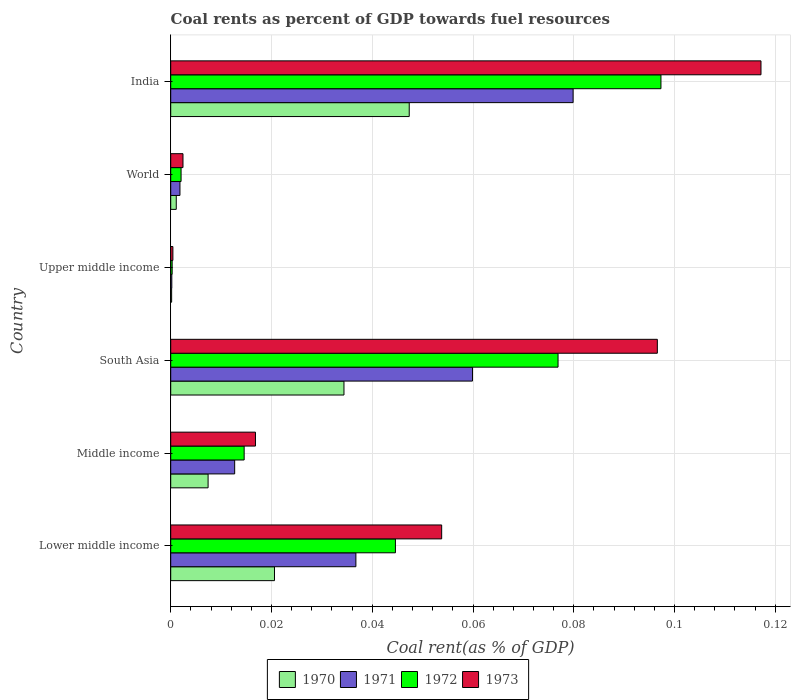How many groups of bars are there?
Offer a terse response. 6. Are the number of bars per tick equal to the number of legend labels?
Provide a succinct answer. Yes. Are the number of bars on each tick of the Y-axis equal?
Your response must be concise. Yes. What is the label of the 5th group of bars from the top?
Give a very brief answer. Middle income. What is the coal rent in 1973 in India?
Make the answer very short. 0.12. Across all countries, what is the maximum coal rent in 1970?
Give a very brief answer. 0.05. Across all countries, what is the minimum coal rent in 1971?
Your response must be concise. 0. In which country was the coal rent in 1970 maximum?
Offer a very short reply. India. In which country was the coal rent in 1970 minimum?
Provide a short and direct response. Upper middle income. What is the total coal rent in 1971 in the graph?
Provide a short and direct response. 0.19. What is the difference between the coal rent in 1970 in South Asia and that in Upper middle income?
Your answer should be very brief. 0.03. What is the difference between the coal rent in 1970 in India and the coal rent in 1971 in Middle income?
Provide a short and direct response. 0.03. What is the average coal rent in 1971 per country?
Provide a succinct answer. 0.03. What is the difference between the coal rent in 1971 and coal rent in 1973 in South Asia?
Your answer should be very brief. -0.04. In how many countries, is the coal rent in 1972 greater than 0.028 %?
Provide a succinct answer. 3. What is the ratio of the coal rent in 1970 in Middle income to that in World?
Your response must be concise. 6.74. Is the difference between the coal rent in 1971 in Middle income and South Asia greater than the difference between the coal rent in 1973 in Middle income and South Asia?
Give a very brief answer. Yes. What is the difference between the highest and the second highest coal rent in 1972?
Make the answer very short. 0.02. What is the difference between the highest and the lowest coal rent in 1972?
Your response must be concise. 0.1. What does the 1st bar from the top in Middle income represents?
Make the answer very short. 1973. What does the 4th bar from the bottom in India represents?
Keep it short and to the point. 1973. Is it the case that in every country, the sum of the coal rent in 1970 and coal rent in 1973 is greater than the coal rent in 1972?
Give a very brief answer. Yes. How many bars are there?
Keep it short and to the point. 24. Are all the bars in the graph horizontal?
Offer a terse response. Yes. Are the values on the major ticks of X-axis written in scientific E-notation?
Offer a terse response. No. Does the graph contain grids?
Offer a terse response. Yes. How many legend labels are there?
Ensure brevity in your answer.  4. How are the legend labels stacked?
Provide a succinct answer. Horizontal. What is the title of the graph?
Give a very brief answer. Coal rents as percent of GDP towards fuel resources. Does "1989" appear as one of the legend labels in the graph?
Give a very brief answer. No. What is the label or title of the X-axis?
Make the answer very short. Coal rent(as % of GDP). What is the Coal rent(as % of GDP) of 1970 in Lower middle income?
Make the answer very short. 0.02. What is the Coal rent(as % of GDP) of 1971 in Lower middle income?
Your answer should be compact. 0.04. What is the Coal rent(as % of GDP) of 1972 in Lower middle income?
Your response must be concise. 0.04. What is the Coal rent(as % of GDP) in 1973 in Lower middle income?
Provide a short and direct response. 0.05. What is the Coal rent(as % of GDP) in 1970 in Middle income?
Provide a short and direct response. 0.01. What is the Coal rent(as % of GDP) in 1971 in Middle income?
Your answer should be very brief. 0.01. What is the Coal rent(as % of GDP) in 1972 in Middle income?
Give a very brief answer. 0.01. What is the Coal rent(as % of GDP) in 1973 in Middle income?
Your response must be concise. 0.02. What is the Coal rent(as % of GDP) in 1970 in South Asia?
Your response must be concise. 0.03. What is the Coal rent(as % of GDP) of 1971 in South Asia?
Your answer should be very brief. 0.06. What is the Coal rent(as % of GDP) of 1972 in South Asia?
Offer a terse response. 0.08. What is the Coal rent(as % of GDP) in 1973 in South Asia?
Your answer should be compact. 0.1. What is the Coal rent(as % of GDP) in 1970 in Upper middle income?
Your answer should be compact. 0. What is the Coal rent(as % of GDP) of 1971 in Upper middle income?
Keep it short and to the point. 0. What is the Coal rent(as % of GDP) in 1972 in Upper middle income?
Provide a succinct answer. 0. What is the Coal rent(as % of GDP) of 1973 in Upper middle income?
Ensure brevity in your answer.  0. What is the Coal rent(as % of GDP) in 1970 in World?
Make the answer very short. 0. What is the Coal rent(as % of GDP) of 1971 in World?
Your answer should be very brief. 0. What is the Coal rent(as % of GDP) of 1972 in World?
Offer a terse response. 0. What is the Coal rent(as % of GDP) of 1973 in World?
Make the answer very short. 0. What is the Coal rent(as % of GDP) in 1970 in India?
Make the answer very short. 0.05. What is the Coal rent(as % of GDP) in 1971 in India?
Give a very brief answer. 0.08. What is the Coal rent(as % of GDP) in 1972 in India?
Your answer should be compact. 0.1. What is the Coal rent(as % of GDP) of 1973 in India?
Your answer should be very brief. 0.12. Across all countries, what is the maximum Coal rent(as % of GDP) in 1970?
Keep it short and to the point. 0.05. Across all countries, what is the maximum Coal rent(as % of GDP) of 1971?
Your response must be concise. 0.08. Across all countries, what is the maximum Coal rent(as % of GDP) of 1972?
Provide a short and direct response. 0.1. Across all countries, what is the maximum Coal rent(as % of GDP) in 1973?
Your answer should be compact. 0.12. Across all countries, what is the minimum Coal rent(as % of GDP) in 1970?
Ensure brevity in your answer.  0. Across all countries, what is the minimum Coal rent(as % of GDP) of 1971?
Make the answer very short. 0. Across all countries, what is the minimum Coal rent(as % of GDP) of 1972?
Provide a succinct answer. 0. Across all countries, what is the minimum Coal rent(as % of GDP) in 1973?
Provide a short and direct response. 0. What is the total Coal rent(as % of GDP) of 1970 in the graph?
Ensure brevity in your answer.  0.11. What is the total Coal rent(as % of GDP) of 1971 in the graph?
Your answer should be compact. 0.19. What is the total Coal rent(as % of GDP) of 1972 in the graph?
Ensure brevity in your answer.  0.24. What is the total Coal rent(as % of GDP) of 1973 in the graph?
Offer a very short reply. 0.29. What is the difference between the Coal rent(as % of GDP) of 1970 in Lower middle income and that in Middle income?
Your answer should be very brief. 0.01. What is the difference between the Coal rent(as % of GDP) in 1971 in Lower middle income and that in Middle income?
Your response must be concise. 0.02. What is the difference between the Coal rent(as % of GDP) in 1973 in Lower middle income and that in Middle income?
Offer a terse response. 0.04. What is the difference between the Coal rent(as % of GDP) of 1970 in Lower middle income and that in South Asia?
Give a very brief answer. -0.01. What is the difference between the Coal rent(as % of GDP) of 1971 in Lower middle income and that in South Asia?
Ensure brevity in your answer.  -0.02. What is the difference between the Coal rent(as % of GDP) of 1972 in Lower middle income and that in South Asia?
Your answer should be very brief. -0.03. What is the difference between the Coal rent(as % of GDP) in 1973 in Lower middle income and that in South Asia?
Make the answer very short. -0.04. What is the difference between the Coal rent(as % of GDP) of 1970 in Lower middle income and that in Upper middle income?
Ensure brevity in your answer.  0.02. What is the difference between the Coal rent(as % of GDP) of 1971 in Lower middle income and that in Upper middle income?
Ensure brevity in your answer.  0.04. What is the difference between the Coal rent(as % of GDP) in 1972 in Lower middle income and that in Upper middle income?
Offer a very short reply. 0.04. What is the difference between the Coal rent(as % of GDP) in 1973 in Lower middle income and that in Upper middle income?
Offer a very short reply. 0.05. What is the difference between the Coal rent(as % of GDP) in 1970 in Lower middle income and that in World?
Make the answer very short. 0.02. What is the difference between the Coal rent(as % of GDP) in 1971 in Lower middle income and that in World?
Keep it short and to the point. 0.03. What is the difference between the Coal rent(as % of GDP) in 1972 in Lower middle income and that in World?
Give a very brief answer. 0.04. What is the difference between the Coal rent(as % of GDP) of 1973 in Lower middle income and that in World?
Provide a succinct answer. 0.05. What is the difference between the Coal rent(as % of GDP) of 1970 in Lower middle income and that in India?
Make the answer very short. -0.03. What is the difference between the Coal rent(as % of GDP) in 1971 in Lower middle income and that in India?
Your response must be concise. -0.04. What is the difference between the Coal rent(as % of GDP) of 1972 in Lower middle income and that in India?
Offer a terse response. -0.05. What is the difference between the Coal rent(as % of GDP) of 1973 in Lower middle income and that in India?
Offer a terse response. -0.06. What is the difference between the Coal rent(as % of GDP) in 1970 in Middle income and that in South Asia?
Give a very brief answer. -0.03. What is the difference between the Coal rent(as % of GDP) of 1971 in Middle income and that in South Asia?
Your response must be concise. -0.05. What is the difference between the Coal rent(as % of GDP) in 1972 in Middle income and that in South Asia?
Provide a succinct answer. -0.06. What is the difference between the Coal rent(as % of GDP) in 1973 in Middle income and that in South Asia?
Keep it short and to the point. -0.08. What is the difference between the Coal rent(as % of GDP) of 1970 in Middle income and that in Upper middle income?
Make the answer very short. 0.01. What is the difference between the Coal rent(as % of GDP) of 1971 in Middle income and that in Upper middle income?
Your answer should be very brief. 0.01. What is the difference between the Coal rent(as % of GDP) in 1972 in Middle income and that in Upper middle income?
Offer a terse response. 0.01. What is the difference between the Coal rent(as % of GDP) in 1973 in Middle income and that in Upper middle income?
Keep it short and to the point. 0.02. What is the difference between the Coal rent(as % of GDP) in 1970 in Middle income and that in World?
Offer a terse response. 0.01. What is the difference between the Coal rent(as % of GDP) of 1971 in Middle income and that in World?
Keep it short and to the point. 0.01. What is the difference between the Coal rent(as % of GDP) in 1972 in Middle income and that in World?
Provide a succinct answer. 0.01. What is the difference between the Coal rent(as % of GDP) in 1973 in Middle income and that in World?
Offer a very short reply. 0.01. What is the difference between the Coal rent(as % of GDP) in 1970 in Middle income and that in India?
Provide a succinct answer. -0.04. What is the difference between the Coal rent(as % of GDP) in 1971 in Middle income and that in India?
Provide a short and direct response. -0.07. What is the difference between the Coal rent(as % of GDP) of 1972 in Middle income and that in India?
Ensure brevity in your answer.  -0.08. What is the difference between the Coal rent(as % of GDP) in 1973 in Middle income and that in India?
Your answer should be very brief. -0.1. What is the difference between the Coal rent(as % of GDP) in 1970 in South Asia and that in Upper middle income?
Make the answer very short. 0.03. What is the difference between the Coal rent(as % of GDP) in 1971 in South Asia and that in Upper middle income?
Offer a terse response. 0.06. What is the difference between the Coal rent(as % of GDP) of 1972 in South Asia and that in Upper middle income?
Offer a very short reply. 0.08. What is the difference between the Coal rent(as % of GDP) in 1973 in South Asia and that in Upper middle income?
Provide a short and direct response. 0.1. What is the difference between the Coal rent(as % of GDP) of 1971 in South Asia and that in World?
Your response must be concise. 0.06. What is the difference between the Coal rent(as % of GDP) in 1972 in South Asia and that in World?
Ensure brevity in your answer.  0.07. What is the difference between the Coal rent(as % of GDP) in 1973 in South Asia and that in World?
Your answer should be very brief. 0.09. What is the difference between the Coal rent(as % of GDP) in 1970 in South Asia and that in India?
Offer a terse response. -0.01. What is the difference between the Coal rent(as % of GDP) in 1971 in South Asia and that in India?
Your answer should be compact. -0.02. What is the difference between the Coal rent(as % of GDP) in 1972 in South Asia and that in India?
Keep it short and to the point. -0.02. What is the difference between the Coal rent(as % of GDP) in 1973 in South Asia and that in India?
Give a very brief answer. -0.02. What is the difference between the Coal rent(as % of GDP) of 1970 in Upper middle income and that in World?
Keep it short and to the point. -0. What is the difference between the Coal rent(as % of GDP) in 1971 in Upper middle income and that in World?
Your response must be concise. -0. What is the difference between the Coal rent(as % of GDP) in 1972 in Upper middle income and that in World?
Your answer should be compact. -0. What is the difference between the Coal rent(as % of GDP) in 1973 in Upper middle income and that in World?
Provide a short and direct response. -0. What is the difference between the Coal rent(as % of GDP) of 1970 in Upper middle income and that in India?
Your response must be concise. -0.05. What is the difference between the Coal rent(as % of GDP) of 1971 in Upper middle income and that in India?
Give a very brief answer. -0.08. What is the difference between the Coal rent(as % of GDP) in 1972 in Upper middle income and that in India?
Offer a terse response. -0.1. What is the difference between the Coal rent(as % of GDP) in 1973 in Upper middle income and that in India?
Keep it short and to the point. -0.12. What is the difference between the Coal rent(as % of GDP) in 1970 in World and that in India?
Offer a terse response. -0.05. What is the difference between the Coal rent(as % of GDP) in 1971 in World and that in India?
Your answer should be compact. -0.08. What is the difference between the Coal rent(as % of GDP) of 1972 in World and that in India?
Provide a short and direct response. -0.1. What is the difference between the Coal rent(as % of GDP) of 1973 in World and that in India?
Your answer should be compact. -0.11. What is the difference between the Coal rent(as % of GDP) in 1970 in Lower middle income and the Coal rent(as % of GDP) in 1971 in Middle income?
Give a very brief answer. 0.01. What is the difference between the Coal rent(as % of GDP) of 1970 in Lower middle income and the Coal rent(as % of GDP) of 1972 in Middle income?
Provide a succinct answer. 0.01. What is the difference between the Coal rent(as % of GDP) in 1970 in Lower middle income and the Coal rent(as % of GDP) in 1973 in Middle income?
Provide a succinct answer. 0. What is the difference between the Coal rent(as % of GDP) in 1971 in Lower middle income and the Coal rent(as % of GDP) in 1972 in Middle income?
Your answer should be very brief. 0.02. What is the difference between the Coal rent(as % of GDP) of 1971 in Lower middle income and the Coal rent(as % of GDP) of 1973 in Middle income?
Provide a short and direct response. 0.02. What is the difference between the Coal rent(as % of GDP) in 1972 in Lower middle income and the Coal rent(as % of GDP) in 1973 in Middle income?
Offer a terse response. 0.03. What is the difference between the Coal rent(as % of GDP) in 1970 in Lower middle income and the Coal rent(as % of GDP) in 1971 in South Asia?
Your answer should be compact. -0.04. What is the difference between the Coal rent(as % of GDP) in 1970 in Lower middle income and the Coal rent(as % of GDP) in 1972 in South Asia?
Offer a very short reply. -0.06. What is the difference between the Coal rent(as % of GDP) in 1970 in Lower middle income and the Coal rent(as % of GDP) in 1973 in South Asia?
Your response must be concise. -0.08. What is the difference between the Coal rent(as % of GDP) of 1971 in Lower middle income and the Coal rent(as % of GDP) of 1972 in South Asia?
Offer a very short reply. -0.04. What is the difference between the Coal rent(as % of GDP) in 1971 in Lower middle income and the Coal rent(as % of GDP) in 1973 in South Asia?
Offer a very short reply. -0.06. What is the difference between the Coal rent(as % of GDP) of 1972 in Lower middle income and the Coal rent(as % of GDP) of 1973 in South Asia?
Your answer should be compact. -0.05. What is the difference between the Coal rent(as % of GDP) in 1970 in Lower middle income and the Coal rent(as % of GDP) in 1971 in Upper middle income?
Your answer should be very brief. 0.02. What is the difference between the Coal rent(as % of GDP) in 1970 in Lower middle income and the Coal rent(as % of GDP) in 1972 in Upper middle income?
Your response must be concise. 0.02. What is the difference between the Coal rent(as % of GDP) of 1970 in Lower middle income and the Coal rent(as % of GDP) of 1973 in Upper middle income?
Provide a succinct answer. 0.02. What is the difference between the Coal rent(as % of GDP) of 1971 in Lower middle income and the Coal rent(as % of GDP) of 1972 in Upper middle income?
Keep it short and to the point. 0.04. What is the difference between the Coal rent(as % of GDP) in 1971 in Lower middle income and the Coal rent(as % of GDP) in 1973 in Upper middle income?
Make the answer very short. 0.04. What is the difference between the Coal rent(as % of GDP) in 1972 in Lower middle income and the Coal rent(as % of GDP) in 1973 in Upper middle income?
Provide a succinct answer. 0.04. What is the difference between the Coal rent(as % of GDP) in 1970 in Lower middle income and the Coal rent(as % of GDP) in 1971 in World?
Offer a very short reply. 0.02. What is the difference between the Coal rent(as % of GDP) in 1970 in Lower middle income and the Coal rent(as % of GDP) in 1972 in World?
Offer a very short reply. 0.02. What is the difference between the Coal rent(as % of GDP) in 1970 in Lower middle income and the Coal rent(as % of GDP) in 1973 in World?
Provide a succinct answer. 0.02. What is the difference between the Coal rent(as % of GDP) in 1971 in Lower middle income and the Coal rent(as % of GDP) in 1972 in World?
Provide a short and direct response. 0.03. What is the difference between the Coal rent(as % of GDP) of 1971 in Lower middle income and the Coal rent(as % of GDP) of 1973 in World?
Give a very brief answer. 0.03. What is the difference between the Coal rent(as % of GDP) of 1972 in Lower middle income and the Coal rent(as % of GDP) of 1973 in World?
Your answer should be very brief. 0.04. What is the difference between the Coal rent(as % of GDP) of 1970 in Lower middle income and the Coal rent(as % of GDP) of 1971 in India?
Keep it short and to the point. -0.06. What is the difference between the Coal rent(as % of GDP) in 1970 in Lower middle income and the Coal rent(as % of GDP) in 1972 in India?
Make the answer very short. -0.08. What is the difference between the Coal rent(as % of GDP) of 1970 in Lower middle income and the Coal rent(as % of GDP) of 1973 in India?
Provide a succinct answer. -0.1. What is the difference between the Coal rent(as % of GDP) of 1971 in Lower middle income and the Coal rent(as % of GDP) of 1972 in India?
Give a very brief answer. -0.06. What is the difference between the Coal rent(as % of GDP) in 1971 in Lower middle income and the Coal rent(as % of GDP) in 1973 in India?
Make the answer very short. -0.08. What is the difference between the Coal rent(as % of GDP) of 1972 in Lower middle income and the Coal rent(as % of GDP) of 1973 in India?
Your answer should be compact. -0.07. What is the difference between the Coal rent(as % of GDP) of 1970 in Middle income and the Coal rent(as % of GDP) of 1971 in South Asia?
Keep it short and to the point. -0.05. What is the difference between the Coal rent(as % of GDP) in 1970 in Middle income and the Coal rent(as % of GDP) in 1972 in South Asia?
Keep it short and to the point. -0.07. What is the difference between the Coal rent(as % of GDP) in 1970 in Middle income and the Coal rent(as % of GDP) in 1973 in South Asia?
Your answer should be compact. -0.09. What is the difference between the Coal rent(as % of GDP) of 1971 in Middle income and the Coal rent(as % of GDP) of 1972 in South Asia?
Your answer should be compact. -0.06. What is the difference between the Coal rent(as % of GDP) of 1971 in Middle income and the Coal rent(as % of GDP) of 1973 in South Asia?
Make the answer very short. -0.08. What is the difference between the Coal rent(as % of GDP) in 1972 in Middle income and the Coal rent(as % of GDP) in 1973 in South Asia?
Provide a succinct answer. -0.08. What is the difference between the Coal rent(as % of GDP) in 1970 in Middle income and the Coal rent(as % of GDP) in 1971 in Upper middle income?
Your response must be concise. 0.01. What is the difference between the Coal rent(as % of GDP) in 1970 in Middle income and the Coal rent(as % of GDP) in 1972 in Upper middle income?
Provide a short and direct response. 0.01. What is the difference between the Coal rent(as % of GDP) of 1970 in Middle income and the Coal rent(as % of GDP) of 1973 in Upper middle income?
Provide a short and direct response. 0.01. What is the difference between the Coal rent(as % of GDP) in 1971 in Middle income and the Coal rent(as % of GDP) in 1972 in Upper middle income?
Give a very brief answer. 0.01. What is the difference between the Coal rent(as % of GDP) of 1971 in Middle income and the Coal rent(as % of GDP) of 1973 in Upper middle income?
Your answer should be very brief. 0.01. What is the difference between the Coal rent(as % of GDP) in 1972 in Middle income and the Coal rent(as % of GDP) in 1973 in Upper middle income?
Your answer should be compact. 0.01. What is the difference between the Coal rent(as % of GDP) of 1970 in Middle income and the Coal rent(as % of GDP) of 1971 in World?
Give a very brief answer. 0.01. What is the difference between the Coal rent(as % of GDP) of 1970 in Middle income and the Coal rent(as % of GDP) of 1972 in World?
Your answer should be compact. 0.01. What is the difference between the Coal rent(as % of GDP) of 1970 in Middle income and the Coal rent(as % of GDP) of 1973 in World?
Make the answer very short. 0.01. What is the difference between the Coal rent(as % of GDP) of 1971 in Middle income and the Coal rent(as % of GDP) of 1972 in World?
Ensure brevity in your answer.  0.01. What is the difference between the Coal rent(as % of GDP) of 1971 in Middle income and the Coal rent(as % of GDP) of 1973 in World?
Your response must be concise. 0.01. What is the difference between the Coal rent(as % of GDP) of 1972 in Middle income and the Coal rent(as % of GDP) of 1973 in World?
Provide a short and direct response. 0.01. What is the difference between the Coal rent(as % of GDP) of 1970 in Middle income and the Coal rent(as % of GDP) of 1971 in India?
Provide a succinct answer. -0.07. What is the difference between the Coal rent(as % of GDP) in 1970 in Middle income and the Coal rent(as % of GDP) in 1972 in India?
Provide a succinct answer. -0.09. What is the difference between the Coal rent(as % of GDP) in 1970 in Middle income and the Coal rent(as % of GDP) in 1973 in India?
Ensure brevity in your answer.  -0.11. What is the difference between the Coal rent(as % of GDP) in 1971 in Middle income and the Coal rent(as % of GDP) in 1972 in India?
Offer a terse response. -0.08. What is the difference between the Coal rent(as % of GDP) in 1971 in Middle income and the Coal rent(as % of GDP) in 1973 in India?
Ensure brevity in your answer.  -0.1. What is the difference between the Coal rent(as % of GDP) of 1972 in Middle income and the Coal rent(as % of GDP) of 1973 in India?
Make the answer very short. -0.1. What is the difference between the Coal rent(as % of GDP) of 1970 in South Asia and the Coal rent(as % of GDP) of 1971 in Upper middle income?
Ensure brevity in your answer.  0.03. What is the difference between the Coal rent(as % of GDP) in 1970 in South Asia and the Coal rent(as % of GDP) in 1972 in Upper middle income?
Make the answer very short. 0.03. What is the difference between the Coal rent(as % of GDP) of 1970 in South Asia and the Coal rent(as % of GDP) of 1973 in Upper middle income?
Ensure brevity in your answer.  0.03. What is the difference between the Coal rent(as % of GDP) of 1971 in South Asia and the Coal rent(as % of GDP) of 1972 in Upper middle income?
Your response must be concise. 0.06. What is the difference between the Coal rent(as % of GDP) of 1971 in South Asia and the Coal rent(as % of GDP) of 1973 in Upper middle income?
Your response must be concise. 0.06. What is the difference between the Coal rent(as % of GDP) of 1972 in South Asia and the Coal rent(as % of GDP) of 1973 in Upper middle income?
Your answer should be compact. 0.08. What is the difference between the Coal rent(as % of GDP) of 1970 in South Asia and the Coal rent(as % of GDP) of 1971 in World?
Provide a succinct answer. 0.03. What is the difference between the Coal rent(as % of GDP) of 1970 in South Asia and the Coal rent(as % of GDP) of 1972 in World?
Provide a short and direct response. 0.03. What is the difference between the Coal rent(as % of GDP) in 1970 in South Asia and the Coal rent(as % of GDP) in 1973 in World?
Your response must be concise. 0.03. What is the difference between the Coal rent(as % of GDP) in 1971 in South Asia and the Coal rent(as % of GDP) in 1972 in World?
Ensure brevity in your answer.  0.06. What is the difference between the Coal rent(as % of GDP) in 1971 in South Asia and the Coal rent(as % of GDP) in 1973 in World?
Your answer should be very brief. 0.06. What is the difference between the Coal rent(as % of GDP) in 1972 in South Asia and the Coal rent(as % of GDP) in 1973 in World?
Ensure brevity in your answer.  0.07. What is the difference between the Coal rent(as % of GDP) in 1970 in South Asia and the Coal rent(as % of GDP) in 1971 in India?
Offer a terse response. -0.05. What is the difference between the Coal rent(as % of GDP) of 1970 in South Asia and the Coal rent(as % of GDP) of 1972 in India?
Offer a terse response. -0.06. What is the difference between the Coal rent(as % of GDP) in 1970 in South Asia and the Coal rent(as % of GDP) in 1973 in India?
Your answer should be very brief. -0.08. What is the difference between the Coal rent(as % of GDP) of 1971 in South Asia and the Coal rent(as % of GDP) of 1972 in India?
Your response must be concise. -0.04. What is the difference between the Coal rent(as % of GDP) of 1971 in South Asia and the Coal rent(as % of GDP) of 1973 in India?
Make the answer very short. -0.06. What is the difference between the Coal rent(as % of GDP) in 1972 in South Asia and the Coal rent(as % of GDP) in 1973 in India?
Your answer should be compact. -0.04. What is the difference between the Coal rent(as % of GDP) of 1970 in Upper middle income and the Coal rent(as % of GDP) of 1971 in World?
Make the answer very short. -0. What is the difference between the Coal rent(as % of GDP) of 1970 in Upper middle income and the Coal rent(as % of GDP) of 1972 in World?
Offer a terse response. -0. What is the difference between the Coal rent(as % of GDP) of 1970 in Upper middle income and the Coal rent(as % of GDP) of 1973 in World?
Provide a succinct answer. -0. What is the difference between the Coal rent(as % of GDP) in 1971 in Upper middle income and the Coal rent(as % of GDP) in 1972 in World?
Your response must be concise. -0. What is the difference between the Coal rent(as % of GDP) in 1971 in Upper middle income and the Coal rent(as % of GDP) in 1973 in World?
Your answer should be compact. -0. What is the difference between the Coal rent(as % of GDP) in 1972 in Upper middle income and the Coal rent(as % of GDP) in 1973 in World?
Provide a short and direct response. -0. What is the difference between the Coal rent(as % of GDP) in 1970 in Upper middle income and the Coal rent(as % of GDP) in 1971 in India?
Make the answer very short. -0.08. What is the difference between the Coal rent(as % of GDP) in 1970 in Upper middle income and the Coal rent(as % of GDP) in 1972 in India?
Your response must be concise. -0.1. What is the difference between the Coal rent(as % of GDP) in 1970 in Upper middle income and the Coal rent(as % of GDP) in 1973 in India?
Offer a terse response. -0.12. What is the difference between the Coal rent(as % of GDP) of 1971 in Upper middle income and the Coal rent(as % of GDP) of 1972 in India?
Your response must be concise. -0.1. What is the difference between the Coal rent(as % of GDP) of 1971 in Upper middle income and the Coal rent(as % of GDP) of 1973 in India?
Your answer should be compact. -0.12. What is the difference between the Coal rent(as % of GDP) of 1972 in Upper middle income and the Coal rent(as % of GDP) of 1973 in India?
Make the answer very short. -0.12. What is the difference between the Coal rent(as % of GDP) of 1970 in World and the Coal rent(as % of GDP) of 1971 in India?
Make the answer very short. -0.08. What is the difference between the Coal rent(as % of GDP) of 1970 in World and the Coal rent(as % of GDP) of 1972 in India?
Make the answer very short. -0.1. What is the difference between the Coal rent(as % of GDP) of 1970 in World and the Coal rent(as % of GDP) of 1973 in India?
Make the answer very short. -0.12. What is the difference between the Coal rent(as % of GDP) of 1971 in World and the Coal rent(as % of GDP) of 1972 in India?
Your answer should be very brief. -0.1. What is the difference between the Coal rent(as % of GDP) in 1971 in World and the Coal rent(as % of GDP) in 1973 in India?
Provide a short and direct response. -0.12. What is the difference between the Coal rent(as % of GDP) of 1972 in World and the Coal rent(as % of GDP) of 1973 in India?
Provide a short and direct response. -0.12. What is the average Coal rent(as % of GDP) of 1970 per country?
Keep it short and to the point. 0.02. What is the average Coal rent(as % of GDP) in 1971 per country?
Provide a succinct answer. 0.03. What is the average Coal rent(as % of GDP) in 1972 per country?
Keep it short and to the point. 0.04. What is the average Coal rent(as % of GDP) in 1973 per country?
Make the answer very short. 0.05. What is the difference between the Coal rent(as % of GDP) in 1970 and Coal rent(as % of GDP) in 1971 in Lower middle income?
Your answer should be compact. -0.02. What is the difference between the Coal rent(as % of GDP) of 1970 and Coal rent(as % of GDP) of 1972 in Lower middle income?
Keep it short and to the point. -0.02. What is the difference between the Coal rent(as % of GDP) in 1970 and Coal rent(as % of GDP) in 1973 in Lower middle income?
Provide a succinct answer. -0.03. What is the difference between the Coal rent(as % of GDP) of 1971 and Coal rent(as % of GDP) of 1972 in Lower middle income?
Offer a terse response. -0.01. What is the difference between the Coal rent(as % of GDP) in 1971 and Coal rent(as % of GDP) in 1973 in Lower middle income?
Your answer should be compact. -0.02. What is the difference between the Coal rent(as % of GDP) of 1972 and Coal rent(as % of GDP) of 1973 in Lower middle income?
Your answer should be compact. -0.01. What is the difference between the Coal rent(as % of GDP) of 1970 and Coal rent(as % of GDP) of 1971 in Middle income?
Ensure brevity in your answer.  -0.01. What is the difference between the Coal rent(as % of GDP) in 1970 and Coal rent(as % of GDP) in 1972 in Middle income?
Offer a very short reply. -0.01. What is the difference between the Coal rent(as % of GDP) in 1970 and Coal rent(as % of GDP) in 1973 in Middle income?
Keep it short and to the point. -0.01. What is the difference between the Coal rent(as % of GDP) in 1971 and Coal rent(as % of GDP) in 1972 in Middle income?
Give a very brief answer. -0. What is the difference between the Coal rent(as % of GDP) of 1971 and Coal rent(as % of GDP) of 1973 in Middle income?
Your response must be concise. -0. What is the difference between the Coal rent(as % of GDP) in 1972 and Coal rent(as % of GDP) in 1973 in Middle income?
Offer a terse response. -0. What is the difference between the Coal rent(as % of GDP) in 1970 and Coal rent(as % of GDP) in 1971 in South Asia?
Ensure brevity in your answer.  -0.03. What is the difference between the Coal rent(as % of GDP) of 1970 and Coal rent(as % of GDP) of 1972 in South Asia?
Make the answer very short. -0.04. What is the difference between the Coal rent(as % of GDP) of 1970 and Coal rent(as % of GDP) of 1973 in South Asia?
Ensure brevity in your answer.  -0.06. What is the difference between the Coal rent(as % of GDP) in 1971 and Coal rent(as % of GDP) in 1972 in South Asia?
Offer a very short reply. -0.02. What is the difference between the Coal rent(as % of GDP) in 1971 and Coal rent(as % of GDP) in 1973 in South Asia?
Your answer should be very brief. -0.04. What is the difference between the Coal rent(as % of GDP) in 1972 and Coal rent(as % of GDP) in 1973 in South Asia?
Offer a very short reply. -0.02. What is the difference between the Coal rent(as % of GDP) of 1970 and Coal rent(as % of GDP) of 1972 in Upper middle income?
Offer a terse response. -0. What is the difference between the Coal rent(as % of GDP) in 1970 and Coal rent(as % of GDP) in 1973 in Upper middle income?
Keep it short and to the point. -0. What is the difference between the Coal rent(as % of GDP) of 1971 and Coal rent(as % of GDP) of 1972 in Upper middle income?
Make the answer very short. -0. What is the difference between the Coal rent(as % of GDP) in 1971 and Coal rent(as % of GDP) in 1973 in Upper middle income?
Provide a succinct answer. -0. What is the difference between the Coal rent(as % of GDP) in 1972 and Coal rent(as % of GDP) in 1973 in Upper middle income?
Ensure brevity in your answer.  -0. What is the difference between the Coal rent(as % of GDP) in 1970 and Coal rent(as % of GDP) in 1971 in World?
Your answer should be compact. -0. What is the difference between the Coal rent(as % of GDP) of 1970 and Coal rent(as % of GDP) of 1972 in World?
Your answer should be very brief. -0. What is the difference between the Coal rent(as % of GDP) in 1970 and Coal rent(as % of GDP) in 1973 in World?
Your response must be concise. -0. What is the difference between the Coal rent(as % of GDP) of 1971 and Coal rent(as % of GDP) of 1972 in World?
Make the answer very short. -0. What is the difference between the Coal rent(as % of GDP) in 1971 and Coal rent(as % of GDP) in 1973 in World?
Keep it short and to the point. -0. What is the difference between the Coal rent(as % of GDP) in 1972 and Coal rent(as % of GDP) in 1973 in World?
Give a very brief answer. -0. What is the difference between the Coal rent(as % of GDP) of 1970 and Coal rent(as % of GDP) of 1971 in India?
Keep it short and to the point. -0.03. What is the difference between the Coal rent(as % of GDP) of 1970 and Coal rent(as % of GDP) of 1972 in India?
Ensure brevity in your answer.  -0.05. What is the difference between the Coal rent(as % of GDP) in 1970 and Coal rent(as % of GDP) in 1973 in India?
Your answer should be very brief. -0.07. What is the difference between the Coal rent(as % of GDP) in 1971 and Coal rent(as % of GDP) in 1972 in India?
Offer a terse response. -0.02. What is the difference between the Coal rent(as % of GDP) of 1971 and Coal rent(as % of GDP) of 1973 in India?
Ensure brevity in your answer.  -0.04. What is the difference between the Coal rent(as % of GDP) of 1972 and Coal rent(as % of GDP) of 1973 in India?
Your answer should be compact. -0.02. What is the ratio of the Coal rent(as % of GDP) of 1970 in Lower middle income to that in Middle income?
Provide a succinct answer. 2.78. What is the ratio of the Coal rent(as % of GDP) in 1971 in Lower middle income to that in Middle income?
Provide a short and direct response. 2.9. What is the ratio of the Coal rent(as % of GDP) of 1972 in Lower middle income to that in Middle income?
Keep it short and to the point. 3.06. What is the ratio of the Coal rent(as % of GDP) in 1973 in Lower middle income to that in Middle income?
Give a very brief answer. 3.2. What is the ratio of the Coal rent(as % of GDP) of 1970 in Lower middle income to that in South Asia?
Provide a short and direct response. 0.6. What is the ratio of the Coal rent(as % of GDP) of 1971 in Lower middle income to that in South Asia?
Your answer should be compact. 0.61. What is the ratio of the Coal rent(as % of GDP) in 1972 in Lower middle income to that in South Asia?
Your answer should be compact. 0.58. What is the ratio of the Coal rent(as % of GDP) in 1973 in Lower middle income to that in South Asia?
Provide a short and direct response. 0.56. What is the ratio of the Coal rent(as % of GDP) of 1970 in Lower middle income to that in Upper middle income?
Make the answer very short. 112.03. What is the ratio of the Coal rent(as % of GDP) of 1971 in Lower middle income to that in Upper middle income?
Keep it short and to the point. 167.98. What is the ratio of the Coal rent(as % of GDP) of 1972 in Lower middle income to that in Upper middle income?
Ensure brevity in your answer.  156.82. What is the ratio of the Coal rent(as % of GDP) in 1973 in Lower middle income to that in Upper middle income?
Offer a very short reply. 124.82. What is the ratio of the Coal rent(as % of GDP) in 1970 in Lower middle income to that in World?
Give a very brief answer. 18.71. What is the ratio of the Coal rent(as % of GDP) of 1971 in Lower middle income to that in World?
Make the answer very short. 20.06. What is the ratio of the Coal rent(as % of GDP) in 1972 in Lower middle income to that in World?
Offer a very short reply. 21.7. What is the ratio of the Coal rent(as % of GDP) in 1973 in Lower middle income to that in World?
Provide a short and direct response. 22.07. What is the ratio of the Coal rent(as % of GDP) of 1970 in Lower middle income to that in India?
Keep it short and to the point. 0.44. What is the ratio of the Coal rent(as % of GDP) in 1971 in Lower middle income to that in India?
Your answer should be very brief. 0.46. What is the ratio of the Coal rent(as % of GDP) of 1972 in Lower middle income to that in India?
Your answer should be compact. 0.46. What is the ratio of the Coal rent(as % of GDP) of 1973 in Lower middle income to that in India?
Your response must be concise. 0.46. What is the ratio of the Coal rent(as % of GDP) in 1970 in Middle income to that in South Asia?
Offer a very short reply. 0.22. What is the ratio of the Coal rent(as % of GDP) of 1971 in Middle income to that in South Asia?
Make the answer very short. 0.21. What is the ratio of the Coal rent(as % of GDP) in 1972 in Middle income to that in South Asia?
Provide a succinct answer. 0.19. What is the ratio of the Coal rent(as % of GDP) in 1973 in Middle income to that in South Asia?
Keep it short and to the point. 0.17. What is the ratio of the Coal rent(as % of GDP) of 1970 in Middle income to that in Upper middle income?
Your response must be concise. 40.36. What is the ratio of the Coal rent(as % of GDP) of 1971 in Middle income to that in Upper middle income?
Your answer should be compact. 58.01. What is the ratio of the Coal rent(as % of GDP) of 1972 in Middle income to that in Upper middle income?
Your response must be concise. 51.25. What is the ratio of the Coal rent(as % of GDP) of 1973 in Middle income to that in Upper middle income?
Provide a short and direct response. 39.04. What is the ratio of the Coal rent(as % of GDP) in 1970 in Middle income to that in World?
Keep it short and to the point. 6.74. What is the ratio of the Coal rent(as % of GDP) of 1971 in Middle income to that in World?
Your response must be concise. 6.93. What is the ratio of the Coal rent(as % of GDP) of 1972 in Middle income to that in World?
Give a very brief answer. 7.09. What is the ratio of the Coal rent(as % of GDP) in 1973 in Middle income to that in World?
Your answer should be very brief. 6.91. What is the ratio of the Coal rent(as % of GDP) of 1970 in Middle income to that in India?
Keep it short and to the point. 0.16. What is the ratio of the Coal rent(as % of GDP) in 1971 in Middle income to that in India?
Your answer should be compact. 0.16. What is the ratio of the Coal rent(as % of GDP) in 1972 in Middle income to that in India?
Keep it short and to the point. 0.15. What is the ratio of the Coal rent(as % of GDP) in 1973 in Middle income to that in India?
Offer a very short reply. 0.14. What is the ratio of the Coal rent(as % of GDP) of 1970 in South Asia to that in Upper middle income?
Ensure brevity in your answer.  187.05. What is the ratio of the Coal rent(as % of GDP) in 1971 in South Asia to that in Upper middle income?
Provide a succinct answer. 273.74. What is the ratio of the Coal rent(as % of GDP) of 1972 in South Asia to that in Upper middle income?
Offer a terse response. 270.32. What is the ratio of the Coal rent(as % of GDP) of 1973 in South Asia to that in Upper middle income?
Give a very brief answer. 224.18. What is the ratio of the Coal rent(as % of GDP) of 1970 in South Asia to that in World?
Ensure brevity in your answer.  31.24. What is the ratio of the Coal rent(as % of GDP) in 1971 in South Asia to that in World?
Give a very brief answer. 32.69. What is the ratio of the Coal rent(as % of GDP) of 1972 in South Asia to that in World?
Your answer should be very brief. 37.41. What is the ratio of the Coal rent(as % of GDP) in 1973 in South Asia to that in World?
Provide a succinct answer. 39.65. What is the ratio of the Coal rent(as % of GDP) in 1970 in South Asia to that in India?
Your answer should be very brief. 0.73. What is the ratio of the Coal rent(as % of GDP) of 1971 in South Asia to that in India?
Offer a terse response. 0.75. What is the ratio of the Coal rent(as % of GDP) of 1972 in South Asia to that in India?
Provide a short and direct response. 0.79. What is the ratio of the Coal rent(as % of GDP) in 1973 in South Asia to that in India?
Ensure brevity in your answer.  0.82. What is the ratio of the Coal rent(as % of GDP) in 1970 in Upper middle income to that in World?
Provide a short and direct response. 0.17. What is the ratio of the Coal rent(as % of GDP) of 1971 in Upper middle income to that in World?
Give a very brief answer. 0.12. What is the ratio of the Coal rent(as % of GDP) in 1972 in Upper middle income to that in World?
Your answer should be very brief. 0.14. What is the ratio of the Coal rent(as % of GDP) of 1973 in Upper middle income to that in World?
Your response must be concise. 0.18. What is the ratio of the Coal rent(as % of GDP) in 1970 in Upper middle income to that in India?
Ensure brevity in your answer.  0. What is the ratio of the Coal rent(as % of GDP) in 1971 in Upper middle income to that in India?
Provide a succinct answer. 0. What is the ratio of the Coal rent(as % of GDP) in 1972 in Upper middle income to that in India?
Keep it short and to the point. 0. What is the ratio of the Coal rent(as % of GDP) in 1973 in Upper middle income to that in India?
Ensure brevity in your answer.  0. What is the ratio of the Coal rent(as % of GDP) of 1970 in World to that in India?
Provide a short and direct response. 0.02. What is the ratio of the Coal rent(as % of GDP) in 1971 in World to that in India?
Ensure brevity in your answer.  0.02. What is the ratio of the Coal rent(as % of GDP) in 1972 in World to that in India?
Your answer should be compact. 0.02. What is the ratio of the Coal rent(as % of GDP) of 1973 in World to that in India?
Your answer should be very brief. 0.02. What is the difference between the highest and the second highest Coal rent(as % of GDP) of 1970?
Ensure brevity in your answer.  0.01. What is the difference between the highest and the second highest Coal rent(as % of GDP) in 1972?
Your response must be concise. 0.02. What is the difference between the highest and the second highest Coal rent(as % of GDP) in 1973?
Offer a terse response. 0.02. What is the difference between the highest and the lowest Coal rent(as % of GDP) in 1970?
Offer a terse response. 0.05. What is the difference between the highest and the lowest Coal rent(as % of GDP) of 1971?
Give a very brief answer. 0.08. What is the difference between the highest and the lowest Coal rent(as % of GDP) in 1972?
Your response must be concise. 0.1. What is the difference between the highest and the lowest Coal rent(as % of GDP) in 1973?
Provide a short and direct response. 0.12. 